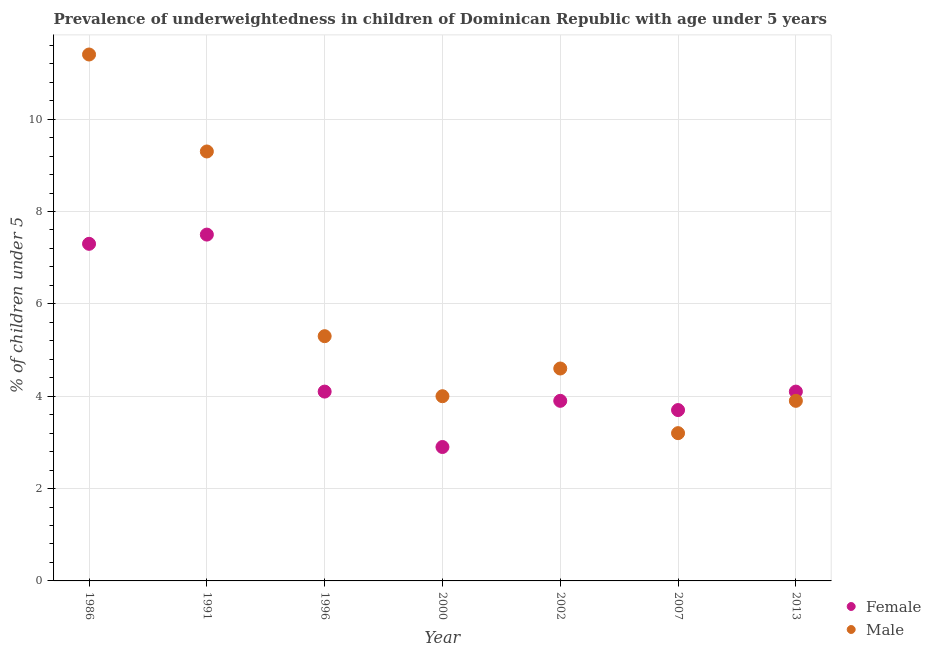Is the number of dotlines equal to the number of legend labels?
Keep it short and to the point. Yes. What is the percentage of underweighted female children in 2000?
Provide a short and direct response. 2.9. Across all years, what is the maximum percentage of underweighted male children?
Provide a succinct answer. 11.4. Across all years, what is the minimum percentage of underweighted female children?
Your answer should be very brief. 2.9. What is the total percentage of underweighted female children in the graph?
Your response must be concise. 33.5. What is the difference between the percentage of underweighted female children in 1991 and that in 2002?
Provide a succinct answer. 3.6. What is the difference between the percentage of underweighted female children in 2013 and the percentage of underweighted male children in 2002?
Keep it short and to the point. -0.5. What is the average percentage of underweighted male children per year?
Give a very brief answer. 5.96. In the year 2007, what is the difference between the percentage of underweighted female children and percentage of underweighted male children?
Make the answer very short. 0.5. What is the ratio of the percentage of underweighted male children in 2000 to that in 2013?
Your answer should be very brief. 1.03. Is the percentage of underweighted female children in 1986 less than that in 1991?
Provide a succinct answer. Yes. Is the difference between the percentage of underweighted male children in 2007 and 2013 greater than the difference between the percentage of underweighted female children in 2007 and 2013?
Provide a short and direct response. No. What is the difference between the highest and the second highest percentage of underweighted female children?
Your response must be concise. 0.2. What is the difference between the highest and the lowest percentage of underweighted male children?
Give a very brief answer. 8.2. In how many years, is the percentage of underweighted female children greater than the average percentage of underweighted female children taken over all years?
Make the answer very short. 2. Is the sum of the percentage of underweighted male children in 1996 and 2000 greater than the maximum percentage of underweighted female children across all years?
Your answer should be compact. Yes. Is the percentage of underweighted female children strictly greater than the percentage of underweighted male children over the years?
Offer a very short reply. No. Is the percentage of underweighted female children strictly less than the percentage of underweighted male children over the years?
Offer a very short reply. No. How many dotlines are there?
Your answer should be compact. 2. What is the difference between two consecutive major ticks on the Y-axis?
Your response must be concise. 2. Does the graph contain any zero values?
Ensure brevity in your answer.  No. Does the graph contain grids?
Make the answer very short. Yes. Where does the legend appear in the graph?
Your answer should be compact. Bottom right. How are the legend labels stacked?
Your answer should be very brief. Vertical. What is the title of the graph?
Provide a succinct answer. Prevalence of underweightedness in children of Dominican Republic with age under 5 years. What is the label or title of the X-axis?
Provide a succinct answer. Year. What is the label or title of the Y-axis?
Provide a short and direct response.  % of children under 5. What is the  % of children under 5 of Female in 1986?
Provide a short and direct response. 7.3. What is the  % of children under 5 of Male in 1986?
Your answer should be very brief. 11.4. What is the  % of children under 5 of Female in 1991?
Your answer should be very brief. 7.5. What is the  % of children under 5 in Male in 1991?
Provide a succinct answer. 9.3. What is the  % of children under 5 of Female in 1996?
Keep it short and to the point. 4.1. What is the  % of children under 5 of Male in 1996?
Give a very brief answer. 5.3. What is the  % of children under 5 in Female in 2000?
Make the answer very short. 2.9. What is the  % of children under 5 in Male in 2000?
Ensure brevity in your answer.  4. What is the  % of children under 5 of Female in 2002?
Ensure brevity in your answer.  3.9. What is the  % of children under 5 in Male in 2002?
Offer a very short reply. 4.6. What is the  % of children under 5 of Female in 2007?
Your response must be concise. 3.7. What is the  % of children under 5 in Male in 2007?
Give a very brief answer. 3.2. What is the  % of children under 5 in Female in 2013?
Ensure brevity in your answer.  4.1. What is the  % of children under 5 in Male in 2013?
Ensure brevity in your answer.  3.9. Across all years, what is the maximum  % of children under 5 of Male?
Offer a very short reply. 11.4. Across all years, what is the minimum  % of children under 5 of Female?
Your answer should be compact. 2.9. Across all years, what is the minimum  % of children under 5 in Male?
Your response must be concise. 3.2. What is the total  % of children under 5 in Female in the graph?
Offer a very short reply. 33.5. What is the total  % of children under 5 in Male in the graph?
Your response must be concise. 41.7. What is the difference between the  % of children under 5 in Female in 1986 and that in 1996?
Provide a succinct answer. 3.2. What is the difference between the  % of children under 5 of Male in 1986 and that in 2000?
Your response must be concise. 7.4. What is the difference between the  % of children under 5 of Male in 1986 and that in 2007?
Your answer should be very brief. 8.2. What is the difference between the  % of children under 5 in Female in 1986 and that in 2013?
Give a very brief answer. 3.2. What is the difference between the  % of children under 5 of Male in 1986 and that in 2013?
Give a very brief answer. 7.5. What is the difference between the  % of children under 5 in Female in 1991 and that in 1996?
Give a very brief answer. 3.4. What is the difference between the  % of children under 5 in Female in 1991 and that in 2013?
Offer a very short reply. 3.4. What is the difference between the  % of children under 5 in Female in 1996 and that in 2000?
Offer a terse response. 1.2. What is the difference between the  % of children under 5 of Male in 1996 and that in 2000?
Offer a very short reply. 1.3. What is the difference between the  % of children under 5 in Female in 1996 and that in 2013?
Provide a succinct answer. 0. What is the difference between the  % of children under 5 in Male in 1996 and that in 2013?
Offer a terse response. 1.4. What is the difference between the  % of children under 5 in Female in 2000 and that in 2002?
Your response must be concise. -1. What is the difference between the  % of children under 5 of Male in 2000 and that in 2007?
Give a very brief answer. 0.8. What is the difference between the  % of children under 5 in Female in 2002 and that in 2007?
Your answer should be compact. 0.2. What is the difference between the  % of children under 5 in Female in 2002 and that in 2013?
Your answer should be very brief. -0.2. What is the difference between the  % of children under 5 of Male in 2002 and that in 2013?
Offer a very short reply. 0.7. What is the difference between the  % of children under 5 of Female in 2007 and that in 2013?
Your answer should be compact. -0.4. What is the difference between the  % of children under 5 of Female in 1986 and the  % of children under 5 of Male in 1996?
Your answer should be compact. 2. What is the difference between the  % of children under 5 in Female in 1986 and the  % of children under 5 in Male in 2007?
Your answer should be very brief. 4.1. What is the difference between the  % of children under 5 of Female in 1991 and the  % of children under 5 of Male in 2000?
Offer a very short reply. 3.5. What is the difference between the  % of children under 5 in Female in 1996 and the  % of children under 5 in Male in 2000?
Make the answer very short. 0.1. What is the difference between the  % of children under 5 in Female in 1996 and the  % of children under 5 in Male in 2002?
Keep it short and to the point. -0.5. What is the difference between the  % of children under 5 of Female in 1996 and the  % of children under 5 of Male in 2007?
Give a very brief answer. 0.9. What is the difference between the  % of children under 5 in Female in 2000 and the  % of children under 5 in Male in 2007?
Your answer should be very brief. -0.3. What is the difference between the  % of children under 5 in Female in 2000 and the  % of children under 5 in Male in 2013?
Your response must be concise. -1. What is the difference between the  % of children under 5 in Female in 2002 and the  % of children under 5 in Male in 2007?
Provide a short and direct response. 0.7. What is the difference between the  % of children under 5 of Female in 2007 and the  % of children under 5 of Male in 2013?
Give a very brief answer. -0.2. What is the average  % of children under 5 in Female per year?
Your response must be concise. 4.79. What is the average  % of children under 5 in Male per year?
Offer a very short reply. 5.96. In the year 1986, what is the difference between the  % of children under 5 of Female and  % of children under 5 of Male?
Provide a succinct answer. -4.1. In the year 1996, what is the difference between the  % of children under 5 in Female and  % of children under 5 in Male?
Keep it short and to the point. -1.2. In the year 2007, what is the difference between the  % of children under 5 in Female and  % of children under 5 in Male?
Offer a terse response. 0.5. What is the ratio of the  % of children under 5 in Female in 1986 to that in 1991?
Your answer should be very brief. 0.97. What is the ratio of the  % of children under 5 in Male in 1986 to that in 1991?
Your answer should be compact. 1.23. What is the ratio of the  % of children under 5 of Female in 1986 to that in 1996?
Your response must be concise. 1.78. What is the ratio of the  % of children under 5 of Male in 1986 to that in 1996?
Provide a short and direct response. 2.15. What is the ratio of the  % of children under 5 of Female in 1986 to that in 2000?
Your response must be concise. 2.52. What is the ratio of the  % of children under 5 of Male in 1986 to that in 2000?
Make the answer very short. 2.85. What is the ratio of the  % of children under 5 in Female in 1986 to that in 2002?
Make the answer very short. 1.87. What is the ratio of the  % of children under 5 in Male in 1986 to that in 2002?
Ensure brevity in your answer.  2.48. What is the ratio of the  % of children under 5 in Female in 1986 to that in 2007?
Your response must be concise. 1.97. What is the ratio of the  % of children under 5 of Male in 1986 to that in 2007?
Give a very brief answer. 3.56. What is the ratio of the  % of children under 5 of Female in 1986 to that in 2013?
Provide a short and direct response. 1.78. What is the ratio of the  % of children under 5 in Male in 1986 to that in 2013?
Offer a terse response. 2.92. What is the ratio of the  % of children under 5 in Female in 1991 to that in 1996?
Ensure brevity in your answer.  1.83. What is the ratio of the  % of children under 5 in Male in 1991 to that in 1996?
Keep it short and to the point. 1.75. What is the ratio of the  % of children under 5 of Female in 1991 to that in 2000?
Make the answer very short. 2.59. What is the ratio of the  % of children under 5 in Male in 1991 to that in 2000?
Provide a succinct answer. 2.33. What is the ratio of the  % of children under 5 of Female in 1991 to that in 2002?
Make the answer very short. 1.92. What is the ratio of the  % of children under 5 in Male in 1991 to that in 2002?
Provide a succinct answer. 2.02. What is the ratio of the  % of children under 5 in Female in 1991 to that in 2007?
Keep it short and to the point. 2.03. What is the ratio of the  % of children under 5 in Male in 1991 to that in 2007?
Ensure brevity in your answer.  2.91. What is the ratio of the  % of children under 5 in Female in 1991 to that in 2013?
Make the answer very short. 1.83. What is the ratio of the  % of children under 5 of Male in 1991 to that in 2013?
Your answer should be compact. 2.38. What is the ratio of the  % of children under 5 of Female in 1996 to that in 2000?
Provide a succinct answer. 1.41. What is the ratio of the  % of children under 5 of Male in 1996 to that in 2000?
Make the answer very short. 1.32. What is the ratio of the  % of children under 5 of Female in 1996 to that in 2002?
Ensure brevity in your answer.  1.05. What is the ratio of the  % of children under 5 of Male in 1996 to that in 2002?
Your answer should be very brief. 1.15. What is the ratio of the  % of children under 5 of Female in 1996 to that in 2007?
Keep it short and to the point. 1.11. What is the ratio of the  % of children under 5 of Male in 1996 to that in 2007?
Offer a very short reply. 1.66. What is the ratio of the  % of children under 5 of Male in 1996 to that in 2013?
Offer a terse response. 1.36. What is the ratio of the  % of children under 5 of Female in 2000 to that in 2002?
Provide a short and direct response. 0.74. What is the ratio of the  % of children under 5 of Male in 2000 to that in 2002?
Offer a very short reply. 0.87. What is the ratio of the  % of children under 5 in Female in 2000 to that in 2007?
Your answer should be compact. 0.78. What is the ratio of the  % of children under 5 in Male in 2000 to that in 2007?
Provide a short and direct response. 1.25. What is the ratio of the  % of children under 5 in Female in 2000 to that in 2013?
Offer a terse response. 0.71. What is the ratio of the  % of children under 5 of Male in 2000 to that in 2013?
Provide a succinct answer. 1.03. What is the ratio of the  % of children under 5 of Female in 2002 to that in 2007?
Make the answer very short. 1.05. What is the ratio of the  % of children under 5 of Male in 2002 to that in 2007?
Your response must be concise. 1.44. What is the ratio of the  % of children under 5 of Female in 2002 to that in 2013?
Offer a very short reply. 0.95. What is the ratio of the  % of children under 5 of Male in 2002 to that in 2013?
Make the answer very short. 1.18. What is the ratio of the  % of children under 5 of Female in 2007 to that in 2013?
Your response must be concise. 0.9. What is the ratio of the  % of children under 5 in Male in 2007 to that in 2013?
Give a very brief answer. 0.82. What is the difference between the highest and the second highest  % of children under 5 in Male?
Your response must be concise. 2.1. What is the difference between the highest and the lowest  % of children under 5 in Female?
Keep it short and to the point. 4.6. 